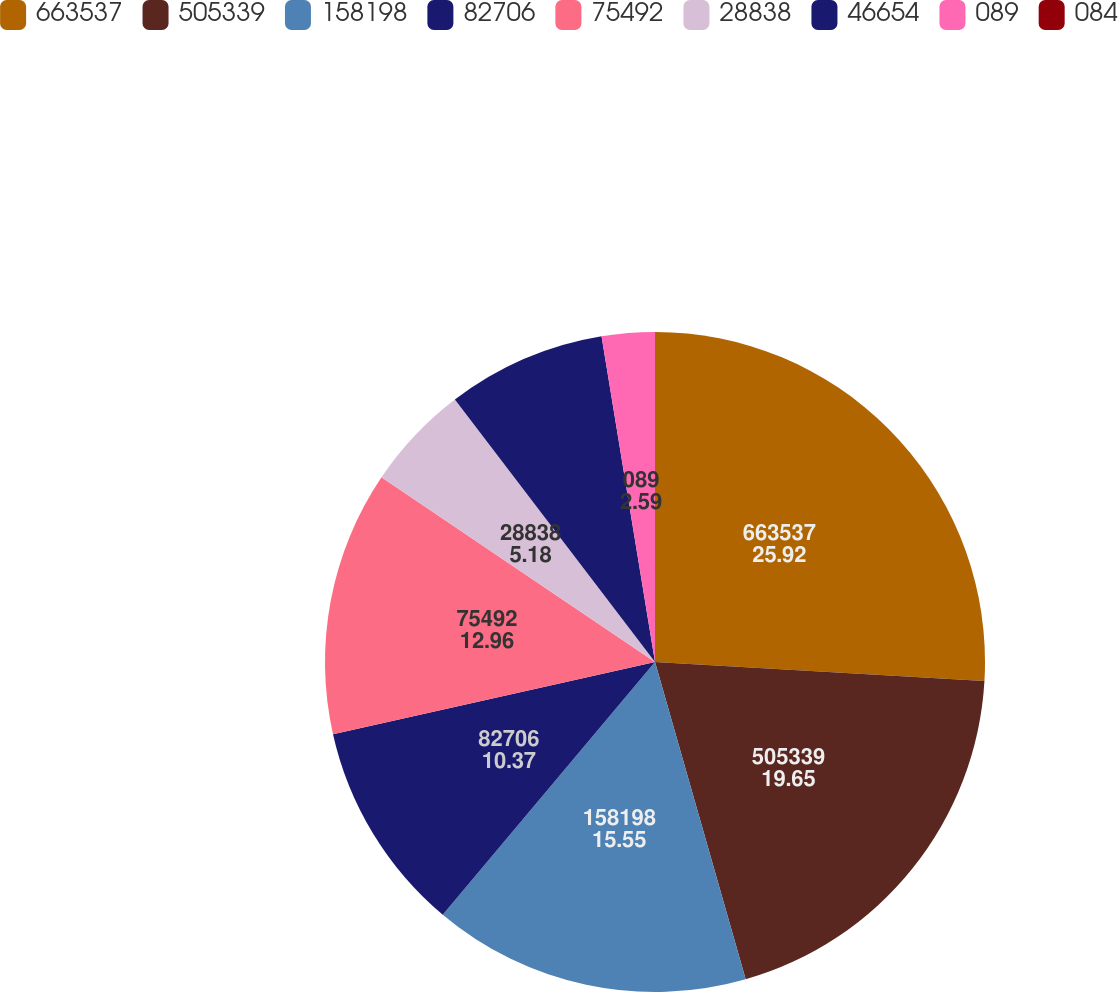<chart> <loc_0><loc_0><loc_500><loc_500><pie_chart><fcel>663537<fcel>505339<fcel>158198<fcel>82706<fcel>75492<fcel>28838<fcel>46654<fcel>089<fcel>084<nl><fcel>25.92%<fcel>19.65%<fcel>15.55%<fcel>10.37%<fcel>12.96%<fcel>5.18%<fcel>7.78%<fcel>2.59%<fcel>0.0%<nl></chart> 